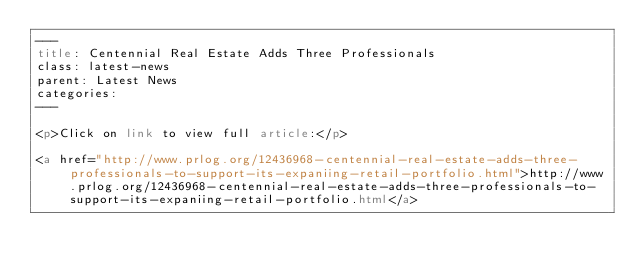<code> <loc_0><loc_0><loc_500><loc_500><_HTML_>---
title: Centennial Real Estate Adds Three Professionals
class: latest-news
parent: Latest News
categories:
---

<p>Click on link to view full article:</p>

<a href="http://www.prlog.org/12436968-centennial-real-estate-adds-three-professionals-to-support-its-expaniing-retail-portfolio.html">http://www.prlog.org/12436968-centennial-real-estate-adds-three-professionals-to-support-its-expaniing-retail-portfolio.html</a>
</code> 